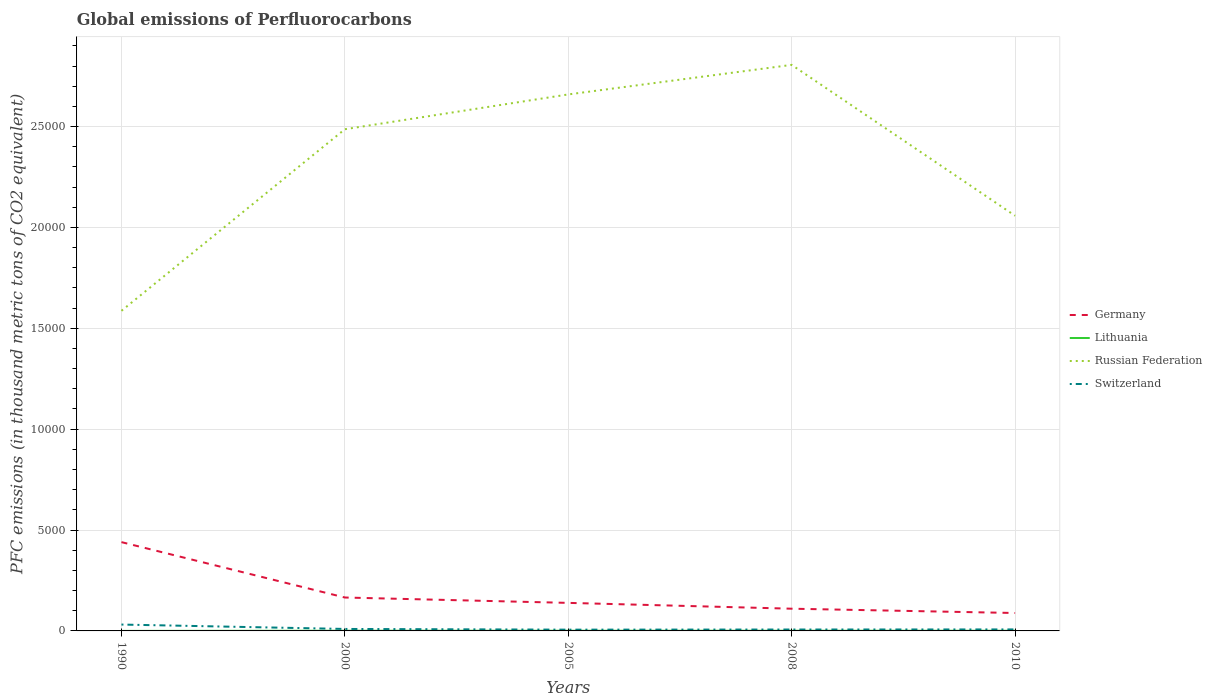Across all years, what is the maximum global emissions of Perfluorocarbons in Russian Federation?
Make the answer very short. 1.59e+04. What is the total global emissions of Perfluorocarbons in Switzerland in the graph?
Provide a succinct answer. 246.1. What is the difference between the highest and the second highest global emissions of Perfluorocarbons in Russian Federation?
Your answer should be compact. 1.22e+04. Is the global emissions of Perfluorocarbons in Lithuania strictly greater than the global emissions of Perfluorocarbons in Germany over the years?
Your response must be concise. Yes. What is the difference between two consecutive major ticks on the Y-axis?
Ensure brevity in your answer.  5000. Does the graph contain any zero values?
Provide a short and direct response. No. How many legend labels are there?
Your answer should be very brief. 4. How are the legend labels stacked?
Provide a short and direct response. Vertical. What is the title of the graph?
Offer a terse response. Global emissions of Perfluorocarbons. What is the label or title of the Y-axis?
Offer a terse response. PFC emissions (in thousand metric tons of CO2 equivalent). What is the PFC emissions (in thousand metric tons of CO2 equivalent) of Germany in 1990?
Provide a short and direct response. 4401.3. What is the PFC emissions (in thousand metric tons of CO2 equivalent) in Lithuania in 1990?
Offer a very short reply. 0.9. What is the PFC emissions (in thousand metric tons of CO2 equivalent) of Russian Federation in 1990?
Provide a succinct answer. 1.59e+04. What is the PFC emissions (in thousand metric tons of CO2 equivalent) in Switzerland in 1990?
Keep it short and to the point. 315.5. What is the PFC emissions (in thousand metric tons of CO2 equivalent) of Germany in 2000?
Ensure brevity in your answer.  1655.9. What is the PFC emissions (in thousand metric tons of CO2 equivalent) in Russian Federation in 2000?
Provide a succinct answer. 2.49e+04. What is the PFC emissions (in thousand metric tons of CO2 equivalent) of Switzerland in 2000?
Offer a terse response. 97.9. What is the PFC emissions (in thousand metric tons of CO2 equivalent) of Germany in 2005?
Your response must be concise. 1389.7. What is the PFC emissions (in thousand metric tons of CO2 equivalent) in Russian Federation in 2005?
Offer a very short reply. 2.66e+04. What is the PFC emissions (in thousand metric tons of CO2 equivalent) of Switzerland in 2005?
Keep it short and to the point. 62.5. What is the PFC emissions (in thousand metric tons of CO2 equivalent) of Germany in 2008?
Ensure brevity in your answer.  1101.4. What is the PFC emissions (in thousand metric tons of CO2 equivalent) of Lithuania in 2008?
Your answer should be compact. 8.2. What is the PFC emissions (in thousand metric tons of CO2 equivalent) in Russian Federation in 2008?
Offer a very short reply. 2.81e+04. What is the PFC emissions (in thousand metric tons of CO2 equivalent) in Switzerland in 2008?
Give a very brief answer. 69.4. What is the PFC emissions (in thousand metric tons of CO2 equivalent) of Germany in 2010?
Ensure brevity in your answer.  888. What is the PFC emissions (in thousand metric tons of CO2 equivalent) in Russian Federation in 2010?
Ensure brevity in your answer.  2.06e+04. What is the PFC emissions (in thousand metric tons of CO2 equivalent) in Switzerland in 2010?
Your response must be concise. 74. Across all years, what is the maximum PFC emissions (in thousand metric tons of CO2 equivalent) of Germany?
Keep it short and to the point. 4401.3. Across all years, what is the maximum PFC emissions (in thousand metric tons of CO2 equivalent) in Lithuania?
Your response must be concise. 8.4. Across all years, what is the maximum PFC emissions (in thousand metric tons of CO2 equivalent) in Russian Federation?
Make the answer very short. 2.81e+04. Across all years, what is the maximum PFC emissions (in thousand metric tons of CO2 equivalent) in Switzerland?
Your response must be concise. 315.5. Across all years, what is the minimum PFC emissions (in thousand metric tons of CO2 equivalent) of Germany?
Offer a terse response. 888. Across all years, what is the minimum PFC emissions (in thousand metric tons of CO2 equivalent) of Russian Federation?
Keep it short and to the point. 1.59e+04. Across all years, what is the minimum PFC emissions (in thousand metric tons of CO2 equivalent) in Switzerland?
Your answer should be compact. 62.5. What is the total PFC emissions (in thousand metric tons of CO2 equivalent) in Germany in the graph?
Your response must be concise. 9436.3. What is the total PFC emissions (in thousand metric tons of CO2 equivalent) of Lithuania in the graph?
Give a very brief answer. 33.7. What is the total PFC emissions (in thousand metric tons of CO2 equivalent) of Russian Federation in the graph?
Your answer should be compact. 1.16e+05. What is the total PFC emissions (in thousand metric tons of CO2 equivalent) in Switzerland in the graph?
Your answer should be very brief. 619.3. What is the difference between the PFC emissions (in thousand metric tons of CO2 equivalent) in Germany in 1990 and that in 2000?
Offer a very short reply. 2745.4. What is the difference between the PFC emissions (in thousand metric tons of CO2 equivalent) of Russian Federation in 1990 and that in 2000?
Provide a succinct answer. -8999.9. What is the difference between the PFC emissions (in thousand metric tons of CO2 equivalent) of Switzerland in 1990 and that in 2000?
Provide a short and direct response. 217.6. What is the difference between the PFC emissions (in thousand metric tons of CO2 equivalent) of Germany in 1990 and that in 2005?
Your response must be concise. 3011.6. What is the difference between the PFC emissions (in thousand metric tons of CO2 equivalent) in Russian Federation in 1990 and that in 2005?
Offer a terse response. -1.07e+04. What is the difference between the PFC emissions (in thousand metric tons of CO2 equivalent) of Switzerland in 1990 and that in 2005?
Give a very brief answer. 253. What is the difference between the PFC emissions (in thousand metric tons of CO2 equivalent) of Germany in 1990 and that in 2008?
Give a very brief answer. 3299.9. What is the difference between the PFC emissions (in thousand metric tons of CO2 equivalent) in Lithuania in 1990 and that in 2008?
Your response must be concise. -7.3. What is the difference between the PFC emissions (in thousand metric tons of CO2 equivalent) of Russian Federation in 1990 and that in 2008?
Make the answer very short. -1.22e+04. What is the difference between the PFC emissions (in thousand metric tons of CO2 equivalent) of Switzerland in 1990 and that in 2008?
Provide a succinct answer. 246.1. What is the difference between the PFC emissions (in thousand metric tons of CO2 equivalent) of Germany in 1990 and that in 2010?
Offer a terse response. 3513.3. What is the difference between the PFC emissions (in thousand metric tons of CO2 equivalent) of Russian Federation in 1990 and that in 2010?
Your answer should be compact. -4711.8. What is the difference between the PFC emissions (in thousand metric tons of CO2 equivalent) in Switzerland in 1990 and that in 2010?
Ensure brevity in your answer.  241.5. What is the difference between the PFC emissions (in thousand metric tons of CO2 equivalent) in Germany in 2000 and that in 2005?
Your answer should be very brief. 266.2. What is the difference between the PFC emissions (in thousand metric tons of CO2 equivalent) of Russian Federation in 2000 and that in 2005?
Ensure brevity in your answer.  -1725.2. What is the difference between the PFC emissions (in thousand metric tons of CO2 equivalent) of Switzerland in 2000 and that in 2005?
Offer a terse response. 35.4. What is the difference between the PFC emissions (in thousand metric tons of CO2 equivalent) in Germany in 2000 and that in 2008?
Your answer should be compact. 554.5. What is the difference between the PFC emissions (in thousand metric tons of CO2 equivalent) of Lithuania in 2000 and that in 2008?
Your response must be concise. 0.2. What is the difference between the PFC emissions (in thousand metric tons of CO2 equivalent) in Russian Federation in 2000 and that in 2008?
Provide a short and direct response. -3189.7. What is the difference between the PFC emissions (in thousand metric tons of CO2 equivalent) in Germany in 2000 and that in 2010?
Your answer should be compact. 767.9. What is the difference between the PFC emissions (in thousand metric tons of CO2 equivalent) in Lithuania in 2000 and that in 2010?
Keep it short and to the point. 0.4. What is the difference between the PFC emissions (in thousand metric tons of CO2 equivalent) of Russian Federation in 2000 and that in 2010?
Offer a terse response. 4288.1. What is the difference between the PFC emissions (in thousand metric tons of CO2 equivalent) of Switzerland in 2000 and that in 2010?
Provide a short and direct response. 23.9. What is the difference between the PFC emissions (in thousand metric tons of CO2 equivalent) of Germany in 2005 and that in 2008?
Give a very brief answer. 288.3. What is the difference between the PFC emissions (in thousand metric tons of CO2 equivalent) of Russian Federation in 2005 and that in 2008?
Make the answer very short. -1464.5. What is the difference between the PFC emissions (in thousand metric tons of CO2 equivalent) in Switzerland in 2005 and that in 2008?
Make the answer very short. -6.9. What is the difference between the PFC emissions (in thousand metric tons of CO2 equivalent) in Germany in 2005 and that in 2010?
Offer a terse response. 501.7. What is the difference between the PFC emissions (in thousand metric tons of CO2 equivalent) in Russian Federation in 2005 and that in 2010?
Make the answer very short. 6013.3. What is the difference between the PFC emissions (in thousand metric tons of CO2 equivalent) in Switzerland in 2005 and that in 2010?
Ensure brevity in your answer.  -11.5. What is the difference between the PFC emissions (in thousand metric tons of CO2 equivalent) of Germany in 2008 and that in 2010?
Ensure brevity in your answer.  213.4. What is the difference between the PFC emissions (in thousand metric tons of CO2 equivalent) of Lithuania in 2008 and that in 2010?
Your response must be concise. 0.2. What is the difference between the PFC emissions (in thousand metric tons of CO2 equivalent) of Russian Federation in 2008 and that in 2010?
Your answer should be very brief. 7477.8. What is the difference between the PFC emissions (in thousand metric tons of CO2 equivalent) in Switzerland in 2008 and that in 2010?
Give a very brief answer. -4.6. What is the difference between the PFC emissions (in thousand metric tons of CO2 equivalent) of Germany in 1990 and the PFC emissions (in thousand metric tons of CO2 equivalent) of Lithuania in 2000?
Provide a short and direct response. 4392.9. What is the difference between the PFC emissions (in thousand metric tons of CO2 equivalent) in Germany in 1990 and the PFC emissions (in thousand metric tons of CO2 equivalent) in Russian Federation in 2000?
Offer a very short reply. -2.05e+04. What is the difference between the PFC emissions (in thousand metric tons of CO2 equivalent) of Germany in 1990 and the PFC emissions (in thousand metric tons of CO2 equivalent) of Switzerland in 2000?
Provide a succinct answer. 4303.4. What is the difference between the PFC emissions (in thousand metric tons of CO2 equivalent) in Lithuania in 1990 and the PFC emissions (in thousand metric tons of CO2 equivalent) in Russian Federation in 2000?
Keep it short and to the point. -2.49e+04. What is the difference between the PFC emissions (in thousand metric tons of CO2 equivalent) of Lithuania in 1990 and the PFC emissions (in thousand metric tons of CO2 equivalent) of Switzerland in 2000?
Your response must be concise. -97. What is the difference between the PFC emissions (in thousand metric tons of CO2 equivalent) in Russian Federation in 1990 and the PFC emissions (in thousand metric tons of CO2 equivalent) in Switzerland in 2000?
Your answer should be compact. 1.58e+04. What is the difference between the PFC emissions (in thousand metric tons of CO2 equivalent) in Germany in 1990 and the PFC emissions (in thousand metric tons of CO2 equivalent) in Lithuania in 2005?
Provide a succinct answer. 4393.1. What is the difference between the PFC emissions (in thousand metric tons of CO2 equivalent) of Germany in 1990 and the PFC emissions (in thousand metric tons of CO2 equivalent) of Russian Federation in 2005?
Your answer should be compact. -2.22e+04. What is the difference between the PFC emissions (in thousand metric tons of CO2 equivalent) of Germany in 1990 and the PFC emissions (in thousand metric tons of CO2 equivalent) of Switzerland in 2005?
Provide a succinct answer. 4338.8. What is the difference between the PFC emissions (in thousand metric tons of CO2 equivalent) of Lithuania in 1990 and the PFC emissions (in thousand metric tons of CO2 equivalent) of Russian Federation in 2005?
Your answer should be very brief. -2.66e+04. What is the difference between the PFC emissions (in thousand metric tons of CO2 equivalent) in Lithuania in 1990 and the PFC emissions (in thousand metric tons of CO2 equivalent) in Switzerland in 2005?
Your answer should be very brief. -61.6. What is the difference between the PFC emissions (in thousand metric tons of CO2 equivalent) of Russian Federation in 1990 and the PFC emissions (in thousand metric tons of CO2 equivalent) of Switzerland in 2005?
Keep it short and to the point. 1.58e+04. What is the difference between the PFC emissions (in thousand metric tons of CO2 equivalent) in Germany in 1990 and the PFC emissions (in thousand metric tons of CO2 equivalent) in Lithuania in 2008?
Your answer should be compact. 4393.1. What is the difference between the PFC emissions (in thousand metric tons of CO2 equivalent) in Germany in 1990 and the PFC emissions (in thousand metric tons of CO2 equivalent) in Russian Federation in 2008?
Offer a very short reply. -2.37e+04. What is the difference between the PFC emissions (in thousand metric tons of CO2 equivalent) in Germany in 1990 and the PFC emissions (in thousand metric tons of CO2 equivalent) in Switzerland in 2008?
Keep it short and to the point. 4331.9. What is the difference between the PFC emissions (in thousand metric tons of CO2 equivalent) of Lithuania in 1990 and the PFC emissions (in thousand metric tons of CO2 equivalent) of Russian Federation in 2008?
Provide a succinct answer. -2.81e+04. What is the difference between the PFC emissions (in thousand metric tons of CO2 equivalent) in Lithuania in 1990 and the PFC emissions (in thousand metric tons of CO2 equivalent) in Switzerland in 2008?
Give a very brief answer. -68.5. What is the difference between the PFC emissions (in thousand metric tons of CO2 equivalent) of Russian Federation in 1990 and the PFC emissions (in thousand metric tons of CO2 equivalent) of Switzerland in 2008?
Your answer should be compact. 1.58e+04. What is the difference between the PFC emissions (in thousand metric tons of CO2 equivalent) of Germany in 1990 and the PFC emissions (in thousand metric tons of CO2 equivalent) of Lithuania in 2010?
Your answer should be very brief. 4393.3. What is the difference between the PFC emissions (in thousand metric tons of CO2 equivalent) of Germany in 1990 and the PFC emissions (in thousand metric tons of CO2 equivalent) of Russian Federation in 2010?
Make the answer very short. -1.62e+04. What is the difference between the PFC emissions (in thousand metric tons of CO2 equivalent) in Germany in 1990 and the PFC emissions (in thousand metric tons of CO2 equivalent) in Switzerland in 2010?
Offer a very short reply. 4327.3. What is the difference between the PFC emissions (in thousand metric tons of CO2 equivalent) of Lithuania in 1990 and the PFC emissions (in thousand metric tons of CO2 equivalent) of Russian Federation in 2010?
Ensure brevity in your answer.  -2.06e+04. What is the difference between the PFC emissions (in thousand metric tons of CO2 equivalent) of Lithuania in 1990 and the PFC emissions (in thousand metric tons of CO2 equivalent) of Switzerland in 2010?
Give a very brief answer. -73.1. What is the difference between the PFC emissions (in thousand metric tons of CO2 equivalent) of Russian Federation in 1990 and the PFC emissions (in thousand metric tons of CO2 equivalent) of Switzerland in 2010?
Offer a terse response. 1.58e+04. What is the difference between the PFC emissions (in thousand metric tons of CO2 equivalent) of Germany in 2000 and the PFC emissions (in thousand metric tons of CO2 equivalent) of Lithuania in 2005?
Your answer should be very brief. 1647.7. What is the difference between the PFC emissions (in thousand metric tons of CO2 equivalent) of Germany in 2000 and the PFC emissions (in thousand metric tons of CO2 equivalent) of Russian Federation in 2005?
Ensure brevity in your answer.  -2.49e+04. What is the difference between the PFC emissions (in thousand metric tons of CO2 equivalent) of Germany in 2000 and the PFC emissions (in thousand metric tons of CO2 equivalent) of Switzerland in 2005?
Provide a short and direct response. 1593.4. What is the difference between the PFC emissions (in thousand metric tons of CO2 equivalent) of Lithuania in 2000 and the PFC emissions (in thousand metric tons of CO2 equivalent) of Russian Federation in 2005?
Your answer should be very brief. -2.66e+04. What is the difference between the PFC emissions (in thousand metric tons of CO2 equivalent) of Lithuania in 2000 and the PFC emissions (in thousand metric tons of CO2 equivalent) of Switzerland in 2005?
Your answer should be compact. -54.1. What is the difference between the PFC emissions (in thousand metric tons of CO2 equivalent) of Russian Federation in 2000 and the PFC emissions (in thousand metric tons of CO2 equivalent) of Switzerland in 2005?
Offer a very short reply. 2.48e+04. What is the difference between the PFC emissions (in thousand metric tons of CO2 equivalent) of Germany in 2000 and the PFC emissions (in thousand metric tons of CO2 equivalent) of Lithuania in 2008?
Offer a very short reply. 1647.7. What is the difference between the PFC emissions (in thousand metric tons of CO2 equivalent) in Germany in 2000 and the PFC emissions (in thousand metric tons of CO2 equivalent) in Russian Federation in 2008?
Ensure brevity in your answer.  -2.64e+04. What is the difference between the PFC emissions (in thousand metric tons of CO2 equivalent) in Germany in 2000 and the PFC emissions (in thousand metric tons of CO2 equivalent) in Switzerland in 2008?
Provide a succinct answer. 1586.5. What is the difference between the PFC emissions (in thousand metric tons of CO2 equivalent) of Lithuania in 2000 and the PFC emissions (in thousand metric tons of CO2 equivalent) of Russian Federation in 2008?
Provide a succinct answer. -2.80e+04. What is the difference between the PFC emissions (in thousand metric tons of CO2 equivalent) of Lithuania in 2000 and the PFC emissions (in thousand metric tons of CO2 equivalent) of Switzerland in 2008?
Ensure brevity in your answer.  -61. What is the difference between the PFC emissions (in thousand metric tons of CO2 equivalent) in Russian Federation in 2000 and the PFC emissions (in thousand metric tons of CO2 equivalent) in Switzerland in 2008?
Provide a short and direct response. 2.48e+04. What is the difference between the PFC emissions (in thousand metric tons of CO2 equivalent) of Germany in 2000 and the PFC emissions (in thousand metric tons of CO2 equivalent) of Lithuania in 2010?
Make the answer very short. 1647.9. What is the difference between the PFC emissions (in thousand metric tons of CO2 equivalent) in Germany in 2000 and the PFC emissions (in thousand metric tons of CO2 equivalent) in Russian Federation in 2010?
Offer a terse response. -1.89e+04. What is the difference between the PFC emissions (in thousand metric tons of CO2 equivalent) in Germany in 2000 and the PFC emissions (in thousand metric tons of CO2 equivalent) in Switzerland in 2010?
Provide a short and direct response. 1581.9. What is the difference between the PFC emissions (in thousand metric tons of CO2 equivalent) of Lithuania in 2000 and the PFC emissions (in thousand metric tons of CO2 equivalent) of Russian Federation in 2010?
Provide a short and direct response. -2.06e+04. What is the difference between the PFC emissions (in thousand metric tons of CO2 equivalent) in Lithuania in 2000 and the PFC emissions (in thousand metric tons of CO2 equivalent) in Switzerland in 2010?
Offer a terse response. -65.6. What is the difference between the PFC emissions (in thousand metric tons of CO2 equivalent) of Russian Federation in 2000 and the PFC emissions (in thousand metric tons of CO2 equivalent) of Switzerland in 2010?
Keep it short and to the point. 2.48e+04. What is the difference between the PFC emissions (in thousand metric tons of CO2 equivalent) of Germany in 2005 and the PFC emissions (in thousand metric tons of CO2 equivalent) of Lithuania in 2008?
Ensure brevity in your answer.  1381.5. What is the difference between the PFC emissions (in thousand metric tons of CO2 equivalent) of Germany in 2005 and the PFC emissions (in thousand metric tons of CO2 equivalent) of Russian Federation in 2008?
Your answer should be compact. -2.67e+04. What is the difference between the PFC emissions (in thousand metric tons of CO2 equivalent) of Germany in 2005 and the PFC emissions (in thousand metric tons of CO2 equivalent) of Switzerland in 2008?
Keep it short and to the point. 1320.3. What is the difference between the PFC emissions (in thousand metric tons of CO2 equivalent) of Lithuania in 2005 and the PFC emissions (in thousand metric tons of CO2 equivalent) of Russian Federation in 2008?
Your answer should be very brief. -2.80e+04. What is the difference between the PFC emissions (in thousand metric tons of CO2 equivalent) in Lithuania in 2005 and the PFC emissions (in thousand metric tons of CO2 equivalent) in Switzerland in 2008?
Ensure brevity in your answer.  -61.2. What is the difference between the PFC emissions (in thousand metric tons of CO2 equivalent) of Russian Federation in 2005 and the PFC emissions (in thousand metric tons of CO2 equivalent) of Switzerland in 2008?
Your answer should be very brief. 2.65e+04. What is the difference between the PFC emissions (in thousand metric tons of CO2 equivalent) in Germany in 2005 and the PFC emissions (in thousand metric tons of CO2 equivalent) in Lithuania in 2010?
Your answer should be compact. 1381.7. What is the difference between the PFC emissions (in thousand metric tons of CO2 equivalent) in Germany in 2005 and the PFC emissions (in thousand metric tons of CO2 equivalent) in Russian Federation in 2010?
Provide a short and direct response. -1.92e+04. What is the difference between the PFC emissions (in thousand metric tons of CO2 equivalent) of Germany in 2005 and the PFC emissions (in thousand metric tons of CO2 equivalent) of Switzerland in 2010?
Your answer should be very brief. 1315.7. What is the difference between the PFC emissions (in thousand metric tons of CO2 equivalent) in Lithuania in 2005 and the PFC emissions (in thousand metric tons of CO2 equivalent) in Russian Federation in 2010?
Provide a short and direct response. -2.06e+04. What is the difference between the PFC emissions (in thousand metric tons of CO2 equivalent) in Lithuania in 2005 and the PFC emissions (in thousand metric tons of CO2 equivalent) in Switzerland in 2010?
Provide a succinct answer. -65.8. What is the difference between the PFC emissions (in thousand metric tons of CO2 equivalent) in Russian Federation in 2005 and the PFC emissions (in thousand metric tons of CO2 equivalent) in Switzerland in 2010?
Offer a very short reply. 2.65e+04. What is the difference between the PFC emissions (in thousand metric tons of CO2 equivalent) in Germany in 2008 and the PFC emissions (in thousand metric tons of CO2 equivalent) in Lithuania in 2010?
Your answer should be very brief. 1093.4. What is the difference between the PFC emissions (in thousand metric tons of CO2 equivalent) of Germany in 2008 and the PFC emissions (in thousand metric tons of CO2 equivalent) of Russian Federation in 2010?
Your answer should be compact. -1.95e+04. What is the difference between the PFC emissions (in thousand metric tons of CO2 equivalent) in Germany in 2008 and the PFC emissions (in thousand metric tons of CO2 equivalent) in Switzerland in 2010?
Keep it short and to the point. 1027.4. What is the difference between the PFC emissions (in thousand metric tons of CO2 equivalent) of Lithuania in 2008 and the PFC emissions (in thousand metric tons of CO2 equivalent) of Russian Federation in 2010?
Make the answer very short. -2.06e+04. What is the difference between the PFC emissions (in thousand metric tons of CO2 equivalent) of Lithuania in 2008 and the PFC emissions (in thousand metric tons of CO2 equivalent) of Switzerland in 2010?
Give a very brief answer. -65.8. What is the difference between the PFC emissions (in thousand metric tons of CO2 equivalent) of Russian Federation in 2008 and the PFC emissions (in thousand metric tons of CO2 equivalent) of Switzerland in 2010?
Keep it short and to the point. 2.80e+04. What is the average PFC emissions (in thousand metric tons of CO2 equivalent) of Germany per year?
Offer a terse response. 1887.26. What is the average PFC emissions (in thousand metric tons of CO2 equivalent) of Lithuania per year?
Keep it short and to the point. 6.74. What is the average PFC emissions (in thousand metric tons of CO2 equivalent) of Russian Federation per year?
Offer a terse response. 2.32e+04. What is the average PFC emissions (in thousand metric tons of CO2 equivalent) of Switzerland per year?
Provide a succinct answer. 123.86. In the year 1990, what is the difference between the PFC emissions (in thousand metric tons of CO2 equivalent) of Germany and PFC emissions (in thousand metric tons of CO2 equivalent) of Lithuania?
Provide a succinct answer. 4400.4. In the year 1990, what is the difference between the PFC emissions (in thousand metric tons of CO2 equivalent) of Germany and PFC emissions (in thousand metric tons of CO2 equivalent) of Russian Federation?
Your answer should be compact. -1.15e+04. In the year 1990, what is the difference between the PFC emissions (in thousand metric tons of CO2 equivalent) in Germany and PFC emissions (in thousand metric tons of CO2 equivalent) in Switzerland?
Your answer should be very brief. 4085.8. In the year 1990, what is the difference between the PFC emissions (in thousand metric tons of CO2 equivalent) in Lithuania and PFC emissions (in thousand metric tons of CO2 equivalent) in Russian Federation?
Your response must be concise. -1.59e+04. In the year 1990, what is the difference between the PFC emissions (in thousand metric tons of CO2 equivalent) in Lithuania and PFC emissions (in thousand metric tons of CO2 equivalent) in Switzerland?
Provide a short and direct response. -314.6. In the year 1990, what is the difference between the PFC emissions (in thousand metric tons of CO2 equivalent) of Russian Federation and PFC emissions (in thousand metric tons of CO2 equivalent) of Switzerland?
Offer a terse response. 1.56e+04. In the year 2000, what is the difference between the PFC emissions (in thousand metric tons of CO2 equivalent) of Germany and PFC emissions (in thousand metric tons of CO2 equivalent) of Lithuania?
Your answer should be compact. 1647.5. In the year 2000, what is the difference between the PFC emissions (in thousand metric tons of CO2 equivalent) in Germany and PFC emissions (in thousand metric tons of CO2 equivalent) in Russian Federation?
Ensure brevity in your answer.  -2.32e+04. In the year 2000, what is the difference between the PFC emissions (in thousand metric tons of CO2 equivalent) in Germany and PFC emissions (in thousand metric tons of CO2 equivalent) in Switzerland?
Make the answer very short. 1558. In the year 2000, what is the difference between the PFC emissions (in thousand metric tons of CO2 equivalent) of Lithuania and PFC emissions (in thousand metric tons of CO2 equivalent) of Russian Federation?
Provide a succinct answer. -2.49e+04. In the year 2000, what is the difference between the PFC emissions (in thousand metric tons of CO2 equivalent) of Lithuania and PFC emissions (in thousand metric tons of CO2 equivalent) of Switzerland?
Provide a short and direct response. -89.5. In the year 2000, what is the difference between the PFC emissions (in thousand metric tons of CO2 equivalent) of Russian Federation and PFC emissions (in thousand metric tons of CO2 equivalent) of Switzerland?
Provide a succinct answer. 2.48e+04. In the year 2005, what is the difference between the PFC emissions (in thousand metric tons of CO2 equivalent) of Germany and PFC emissions (in thousand metric tons of CO2 equivalent) of Lithuania?
Provide a succinct answer. 1381.5. In the year 2005, what is the difference between the PFC emissions (in thousand metric tons of CO2 equivalent) in Germany and PFC emissions (in thousand metric tons of CO2 equivalent) in Russian Federation?
Offer a terse response. -2.52e+04. In the year 2005, what is the difference between the PFC emissions (in thousand metric tons of CO2 equivalent) in Germany and PFC emissions (in thousand metric tons of CO2 equivalent) in Switzerland?
Your answer should be compact. 1327.2. In the year 2005, what is the difference between the PFC emissions (in thousand metric tons of CO2 equivalent) of Lithuania and PFC emissions (in thousand metric tons of CO2 equivalent) of Russian Federation?
Your answer should be very brief. -2.66e+04. In the year 2005, what is the difference between the PFC emissions (in thousand metric tons of CO2 equivalent) in Lithuania and PFC emissions (in thousand metric tons of CO2 equivalent) in Switzerland?
Your answer should be very brief. -54.3. In the year 2005, what is the difference between the PFC emissions (in thousand metric tons of CO2 equivalent) of Russian Federation and PFC emissions (in thousand metric tons of CO2 equivalent) of Switzerland?
Provide a succinct answer. 2.65e+04. In the year 2008, what is the difference between the PFC emissions (in thousand metric tons of CO2 equivalent) of Germany and PFC emissions (in thousand metric tons of CO2 equivalent) of Lithuania?
Your answer should be very brief. 1093.2. In the year 2008, what is the difference between the PFC emissions (in thousand metric tons of CO2 equivalent) of Germany and PFC emissions (in thousand metric tons of CO2 equivalent) of Russian Federation?
Offer a very short reply. -2.70e+04. In the year 2008, what is the difference between the PFC emissions (in thousand metric tons of CO2 equivalent) of Germany and PFC emissions (in thousand metric tons of CO2 equivalent) of Switzerland?
Keep it short and to the point. 1032. In the year 2008, what is the difference between the PFC emissions (in thousand metric tons of CO2 equivalent) of Lithuania and PFC emissions (in thousand metric tons of CO2 equivalent) of Russian Federation?
Make the answer very short. -2.80e+04. In the year 2008, what is the difference between the PFC emissions (in thousand metric tons of CO2 equivalent) in Lithuania and PFC emissions (in thousand metric tons of CO2 equivalent) in Switzerland?
Make the answer very short. -61.2. In the year 2008, what is the difference between the PFC emissions (in thousand metric tons of CO2 equivalent) of Russian Federation and PFC emissions (in thousand metric tons of CO2 equivalent) of Switzerland?
Your answer should be very brief. 2.80e+04. In the year 2010, what is the difference between the PFC emissions (in thousand metric tons of CO2 equivalent) of Germany and PFC emissions (in thousand metric tons of CO2 equivalent) of Lithuania?
Give a very brief answer. 880. In the year 2010, what is the difference between the PFC emissions (in thousand metric tons of CO2 equivalent) in Germany and PFC emissions (in thousand metric tons of CO2 equivalent) in Russian Federation?
Your answer should be very brief. -1.97e+04. In the year 2010, what is the difference between the PFC emissions (in thousand metric tons of CO2 equivalent) of Germany and PFC emissions (in thousand metric tons of CO2 equivalent) of Switzerland?
Provide a succinct answer. 814. In the year 2010, what is the difference between the PFC emissions (in thousand metric tons of CO2 equivalent) of Lithuania and PFC emissions (in thousand metric tons of CO2 equivalent) of Russian Federation?
Offer a very short reply. -2.06e+04. In the year 2010, what is the difference between the PFC emissions (in thousand metric tons of CO2 equivalent) of Lithuania and PFC emissions (in thousand metric tons of CO2 equivalent) of Switzerland?
Keep it short and to the point. -66. In the year 2010, what is the difference between the PFC emissions (in thousand metric tons of CO2 equivalent) of Russian Federation and PFC emissions (in thousand metric tons of CO2 equivalent) of Switzerland?
Offer a very short reply. 2.05e+04. What is the ratio of the PFC emissions (in thousand metric tons of CO2 equivalent) of Germany in 1990 to that in 2000?
Keep it short and to the point. 2.66. What is the ratio of the PFC emissions (in thousand metric tons of CO2 equivalent) of Lithuania in 1990 to that in 2000?
Make the answer very short. 0.11. What is the ratio of the PFC emissions (in thousand metric tons of CO2 equivalent) of Russian Federation in 1990 to that in 2000?
Provide a succinct answer. 0.64. What is the ratio of the PFC emissions (in thousand metric tons of CO2 equivalent) of Switzerland in 1990 to that in 2000?
Give a very brief answer. 3.22. What is the ratio of the PFC emissions (in thousand metric tons of CO2 equivalent) in Germany in 1990 to that in 2005?
Your answer should be compact. 3.17. What is the ratio of the PFC emissions (in thousand metric tons of CO2 equivalent) of Lithuania in 1990 to that in 2005?
Your answer should be compact. 0.11. What is the ratio of the PFC emissions (in thousand metric tons of CO2 equivalent) in Russian Federation in 1990 to that in 2005?
Make the answer very short. 0.6. What is the ratio of the PFC emissions (in thousand metric tons of CO2 equivalent) of Switzerland in 1990 to that in 2005?
Offer a terse response. 5.05. What is the ratio of the PFC emissions (in thousand metric tons of CO2 equivalent) in Germany in 1990 to that in 2008?
Offer a terse response. 4. What is the ratio of the PFC emissions (in thousand metric tons of CO2 equivalent) in Lithuania in 1990 to that in 2008?
Your response must be concise. 0.11. What is the ratio of the PFC emissions (in thousand metric tons of CO2 equivalent) in Russian Federation in 1990 to that in 2008?
Give a very brief answer. 0.57. What is the ratio of the PFC emissions (in thousand metric tons of CO2 equivalent) of Switzerland in 1990 to that in 2008?
Your answer should be compact. 4.55. What is the ratio of the PFC emissions (in thousand metric tons of CO2 equivalent) in Germany in 1990 to that in 2010?
Keep it short and to the point. 4.96. What is the ratio of the PFC emissions (in thousand metric tons of CO2 equivalent) in Lithuania in 1990 to that in 2010?
Provide a short and direct response. 0.11. What is the ratio of the PFC emissions (in thousand metric tons of CO2 equivalent) in Russian Federation in 1990 to that in 2010?
Offer a terse response. 0.77. What is the ratio of the PFC emissions (in thousand metric tons of CO2 equivalent) in Switzerland in 1990 to that in 2010?
Keep it short and to the point. 4.26. What is the ratio of the PFC emissions (in thousand metric tons of CO2 equivalent) of Germany in 2000 to that in 2005?
Make the answer very short. 1.19. What is the ratio of the PFC emissions (in thousand metric tons of CO2 equivalent) in Lithuania in 2000 to that in 2005?
Provide a short and direct response. 1.02. What is the ratio of the PFC emissions (in thousand metric tons of CO2 equivalent) of Russian Federation in 2000 to that in 2005?
Give a very brief answer. 0.94. What is the ratio of the PFC emissions (in thousand metric tons of CO2 equivalent) in Switzerland in 2000 to that in 2005?
Provide a succinct answer. 1.57. What is the ratio of the PFC emissions (in thousand metric tons of CO2 equivalent) of Germany in 2000 to that in 2008?
Provide a short and direct response. 1.5. What is the ratio of the PFC emissions (in thousand metric tons of CO2 equivalent) in Lithuania in 2000 to that in 2008?
Your answer should be very brief. 1.02. What is the ratio of the PFC emissions (in thousand metric tons of CO2 equivalent) of Russian Federation in 2000 to that in 2008?
Ensure brevity in your answer.  0.89. What is the ratio of the PFC emissions (in thousand metric tons of CO2 equivalent) of Switzerland in 2000 to that in 2008?
Offer a terse response. 1.41. What is the ratio of the PFC emissions (in thousand metric tons of CO2 equivalent) of Germany in 2000 to that in 2010?
Your response must be concise. 1.86. What is the ratio of the PFC emissions (in thousand metric tons of CO2 equivalent) in Russian Federation in 2000 to that in 2010?
Your answer should be compact. 1.21. What is the ratio of the PFC emissions (in thousand metric tons of CO2 equivalent) in Switzerland in 2000 to that in 2010?
Keep it short and to the point. 1.32. What is the ratio of the PFC emissions (in thousand metric tons of CO2 equivalent) in Germany in 2005 to that in 2008?
Offer a very short reply. 1.26. What is the ratio of the PFC emissions (in thousand metric tons of CO2 equivalent) in Russian Federation in 2005 to that in 2008?
Give a very brief answer. 0.95. What is the ratio of the PFC emissions (in thousand metric tons of CO2 equivalent) in Switzerland in 2005 to that in 2008?
Your response must be concise. 0.9. What is the ratio of the PFC emissions (in thousand metric tons of CO2 equivalent) of Germany in 2005 to that in 2010?
Make the answer very short. 1.56. What is the ratio of the PFC emissions (in thousand metric tons of CO2 equivalent) of Russian Federation in 2005 to that in 2010?
Give a very brief answer. 1.29. What is the ratio of the PFC emissions (in thousand metric tons of CO2 equivalent) of Switzerland in 2005 to that in 2010?
Your answer should be compact. 0.84. What is the ratio of the PFC emissions (in thousand metric tons of CO2 equivalent) of Germany in 2008 to that in 2010?
Offer a very short reply. 1.24. What is the ratio of the PFC emissions (in thousand metric tons of CO2 equivalent) of Russian Federation in 2008 to that in 2010?
Offer a terse response. 1.36. What is the ratio of the PFC emissions (in thousand metric tons of CO2 equivalent) in Switzerland in 2008 to that in 2010?
Offer a terse response. 0.94. What is the difference between the highest and the second highest PFC emissions (in thousand metric tons of CO2 equivalent) of Germany?
Keep it short and to the point. 2745.4. What is the difference between the highest and the second highest PFC emissions (in thousand metric tons of CO2 equivalent) of Lithuania?
Make the answer very short. 0.2. What is the difference between the highest and the second highest PFC emissions (in thousand metric tons of CO2 equivalent) in Russian Federation?
Your answer should be very brief. 1464.5. What is the difference between the highest and the second highest PFC emissions (in thousand metric tons of CO2 equivalent) in Switzerland?
Make the answer very short. 217.6. What is the difference between the highest and the lowest PFC emissions (in thousand metric tons of CO2 equivalent) of Germany?
Your answer should be compact. 3513.3. What is the difference between the highest and the lowest PFC emissions (in thousand metric tons of CO2 equivalent) of Russian Federation?
Ensure brevity in your answer.  1.22e+04. What is the difference between the highest and the lowest PFC emissions (in thousand metric tons of CO2 equivalent) of Switzerland?
Ensure brevity in your answer.  253. 